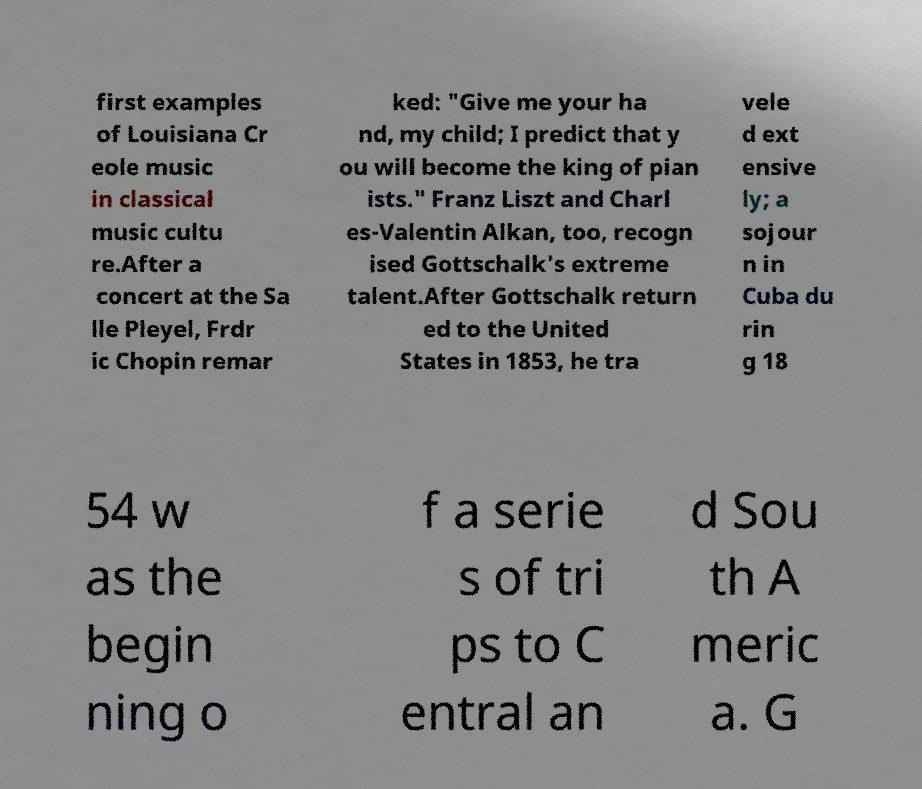Could you extract and type out the text from this image? first examples of Louisiana Cr eole music in classical music cultu re.After a concert at the Sa lle Pleyel, Frdr ic Chopin remar ked: "Give me your ha nd, my child; I predict that y ou will become the king of pian ists." Franz Liszt and Charl es-Valentin Alkan, too, recogn ised Gottschalk's extreme talent.After Gottschalk return ed to the United States in 1853, he tra vele d ext ensive ly; a sojour n in Cuba du rin g 18 54 w as the begin ning o f a serie s of tri ps to C entral an d Sou th A meric a. G 